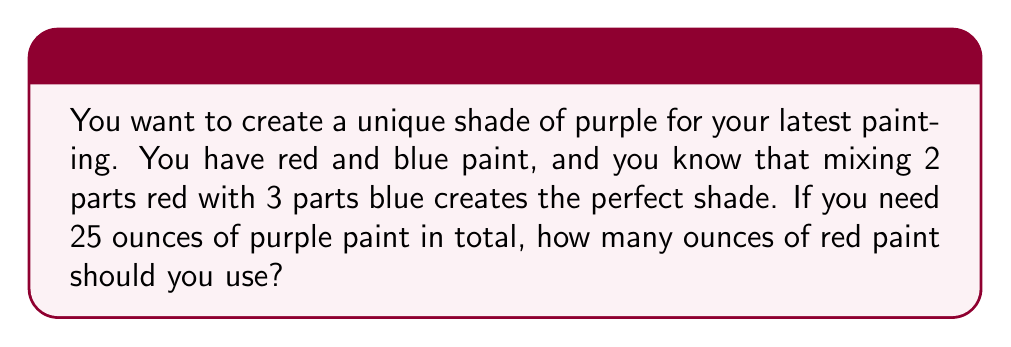Can you answer this question? Let's approach this step-by-step:

1) First, let's identify the ratio of red to blue paint:
   Red : Blue = 2 : 3

2) Now, let's find the total parts in this mixture:
   Total parts = Red parts + Blue parts = 2 + 3 = 5 parts

3) We need to find out how much one "part" represents in our 25-ounce total:
   $\frac{25 \text{ ounces}}{\text{5 parts}} = 5 \text{ ounces per part}$

4) Since we need 2 parts of red paint, we can calculate the amount of red paint:
   Red paint = 2 parts × 5 ounces per part
   $\text{Red paint} = 2 \times 5 = 10 \text{ ounces}$

Therefore, to create 25 ounces of your perfect purple shade, you need 10 ounces of red paint.
Answer: 10 ounces 